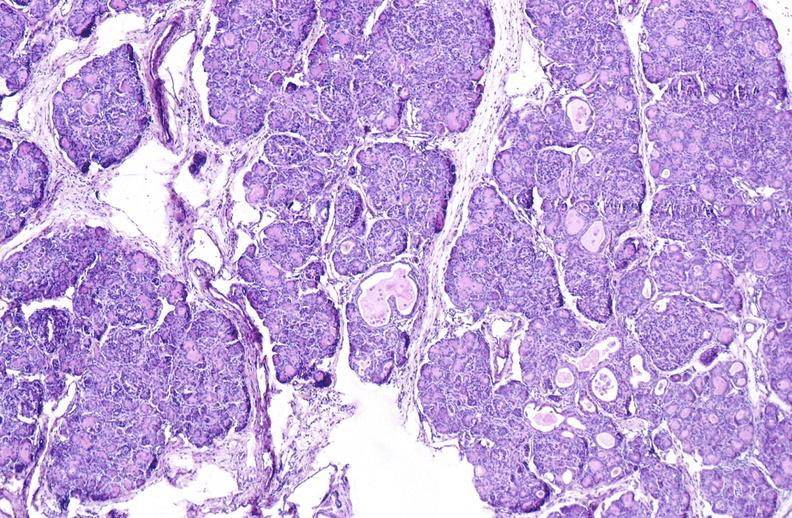s pancreas present?
Answer the question using a single word or phrase. Yes 